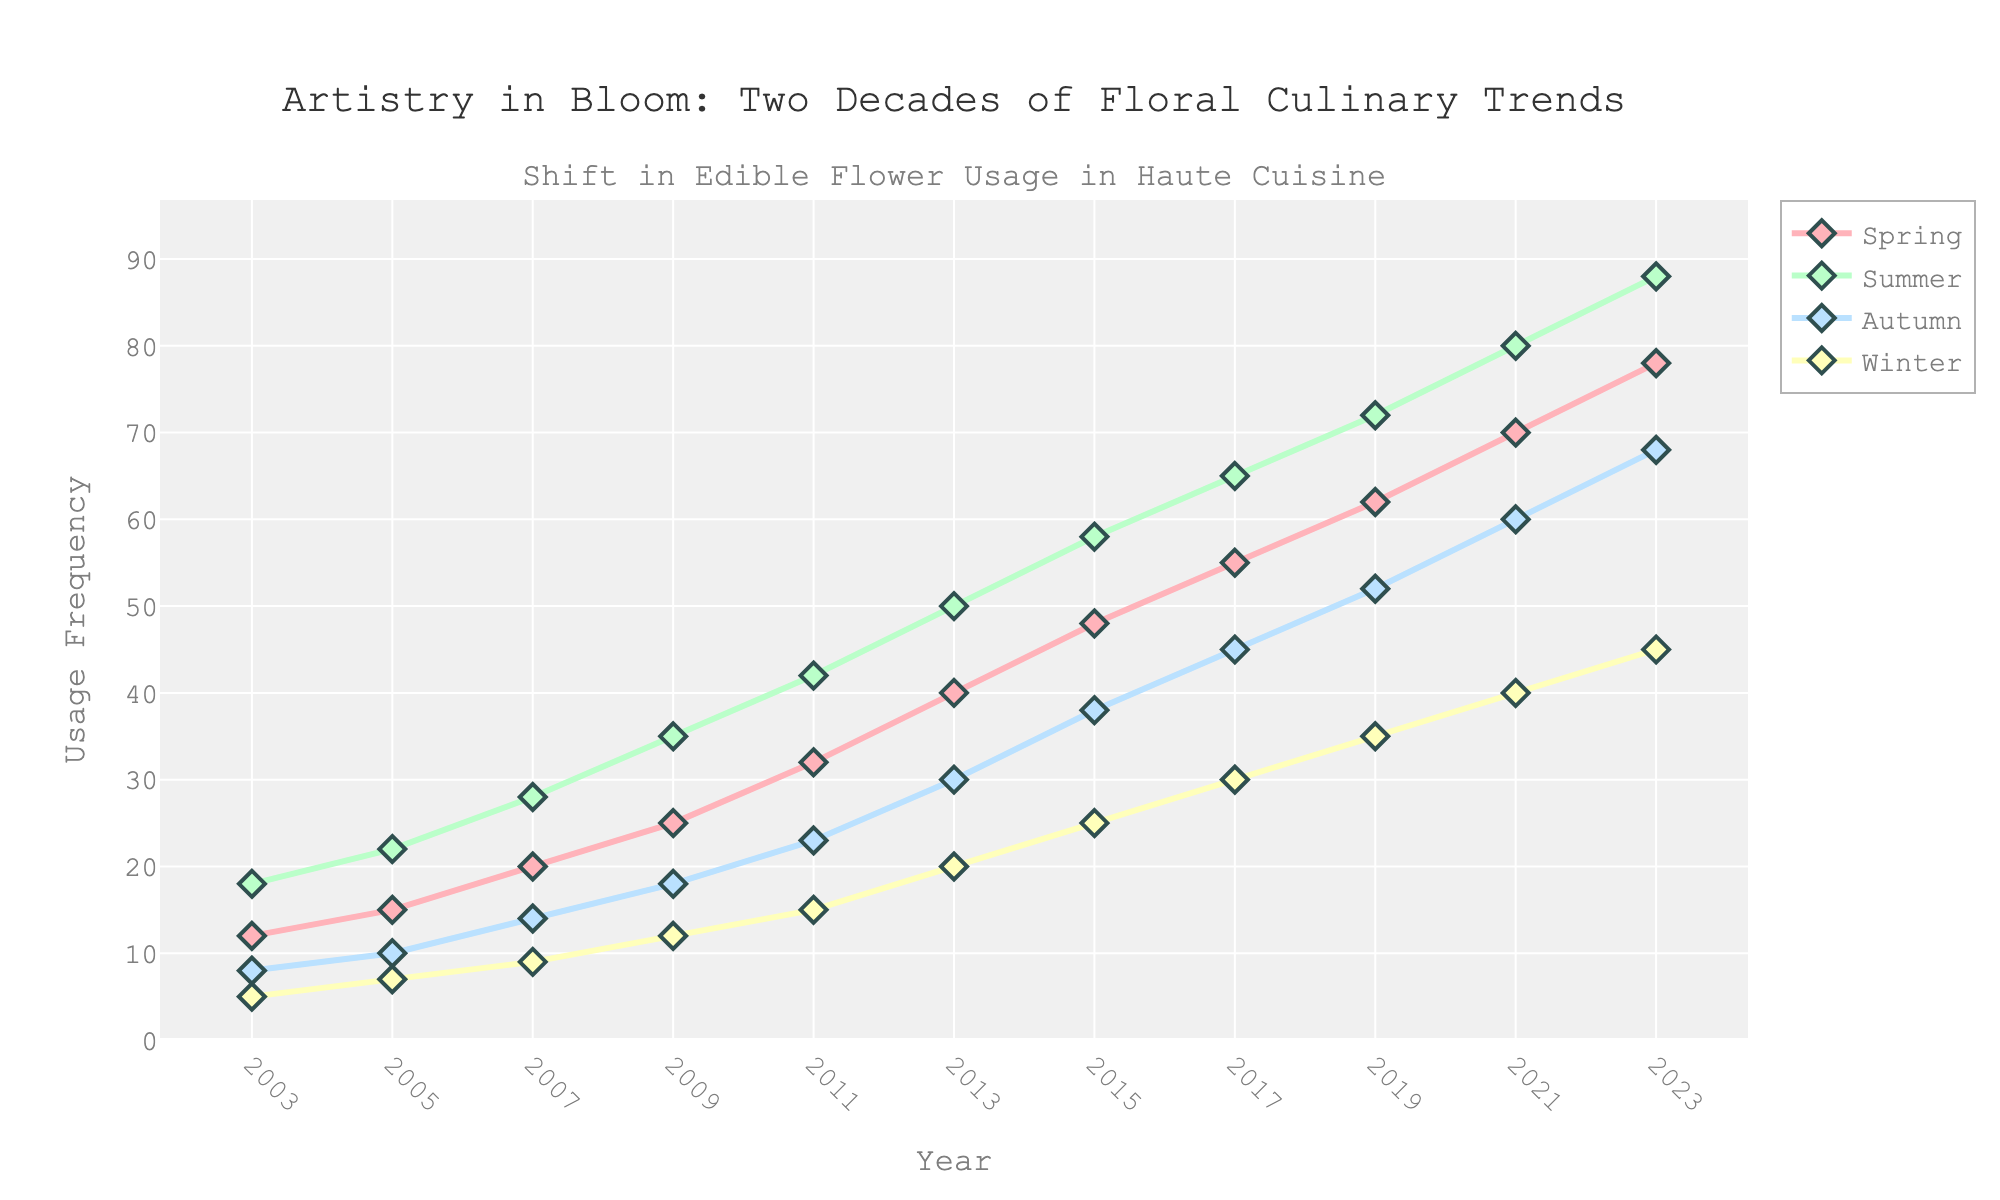What season had the highest usage of edible flowers in 2023? Look at the data points for 2023 and identify which season has the highest value. Summer has the highest value at 88.
Answer: Summer How has the usage of edible flowers in Spring changed from 2003 to 2023? Find the values for Spring in 2003 and 2023, then calculate the difference. The value in 2003 is 12, and in 2023 it is 78. The change is 78 - 12 = 66.
Answer: Increased by 66 Which season experienced the smallest increase in usage of edible flowers from 2003 to 2023? Compare the differences for each season from 2003 to 2023: Spring (78-12=66), Summer (88-18=70), Autumn (68-8=60), Winter (45-5=40). The smallest increase is in Winter with a change of 40.
Answer: Winter What is the average usage of edible flowers in Summer for the years 2003, 2013, and 2023? Take the values for Summer in those years (2003: 18, 2013: 50, 2023: 88), then calculate the average. (18 + 50 + 88) / 3 = 52
Answer: 52 Compare the usage of edible flowers in Autumn and Winter in 2011. Which is higher, and by how much? Find the values for Autumn and Winter in 2011, which are 23 and 15 respectively. Calculate the difference: 23 - 15 = 8. Autumn usage is higher by 8.
Answer: Autumn by 8 What is the general trend for the usage of edible flowers across all seasons from 2003 to 2023? Observe the overall direction of the lines for each season; they all show an increasing trend.
Answer: Increasing Calculate the difference in usage of edible flowers between Spring and Summer in 2009. Find the values for Spring and Summer in 2009: Spring is 25, Summer is 35. Subtract the values: 35 - 25 = 10
Answer: 10 Which season had the highest growth rate between 2019 and 2023? Calculate the growth rate for each season from 2019 to 2023: Spring (78-62=16), Summer (88-72=16), Autumn (68-52=16), Winter (45-35=10). They all had equal growth except Winter.
Answer: Spring, Summer, and Autumn What is the usage frequency gradient between Autumn and Winter in 2023? Find the values for Autumn and Winter in 2023: Autumn is 68 and Winter is 45. Subtract the values: 68 - 45 = 23
Answer: 23 Describe the visual characteristics of the lines representing the seasons in the plot. The lines representing the seasons are colored differently: Spring (Pink), Summer (Green), Autumn (Blue), Winter (Yellow). They also have markers in the shape of diamonds with dark outlines. All lines have an upward slope indicating increased usage.
Answer: Different colors, diamond markers, upward trend 